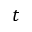<formula> <loc_0><loc_0><loc_500><loc_500>t</formula> 